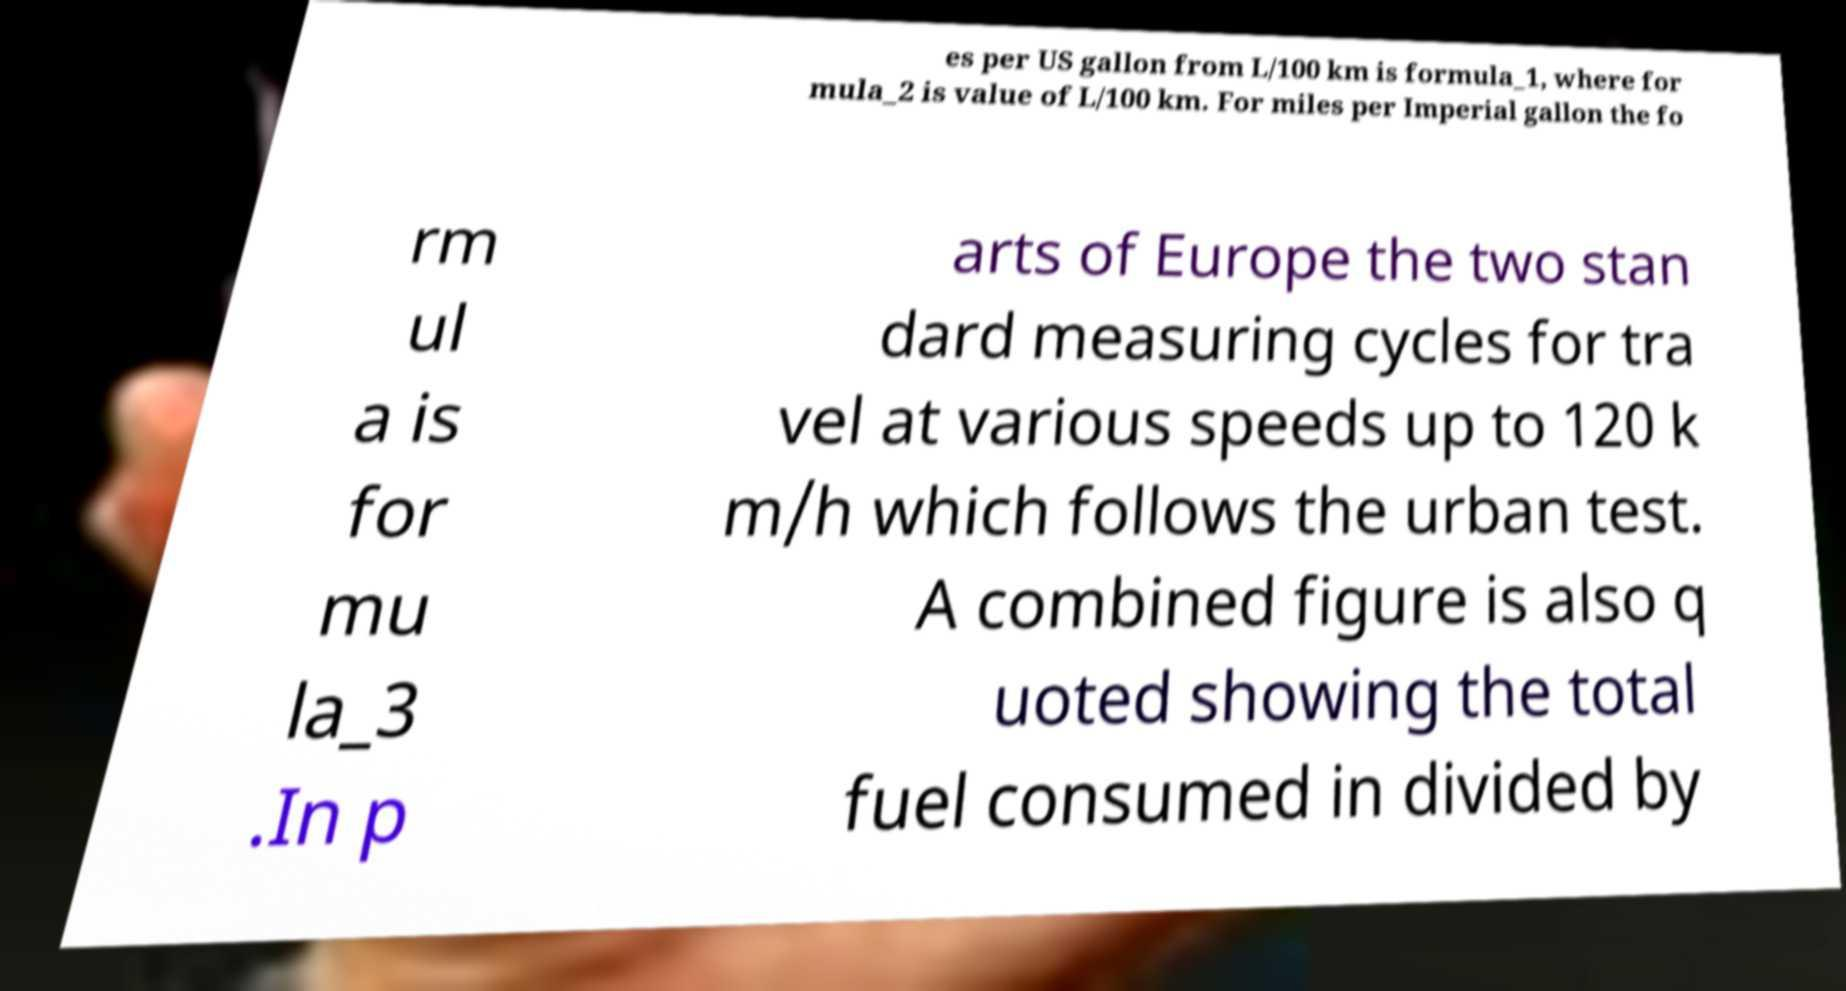Could you assist in decoding the text presented in this image and type it out clearly? es per US gallon from L/100 km is formula_1, where for mula_2 is value of L/100 km. For miles per Imperial gallon the fo rm ul a is for mu la_3 .In p arts of Europe the two stan dard measuring cycles for tra vel at various speeds up to 120 k m/h which follows the urban test. A combined figure is also q uoted showing the total fuel consumed in divided by 